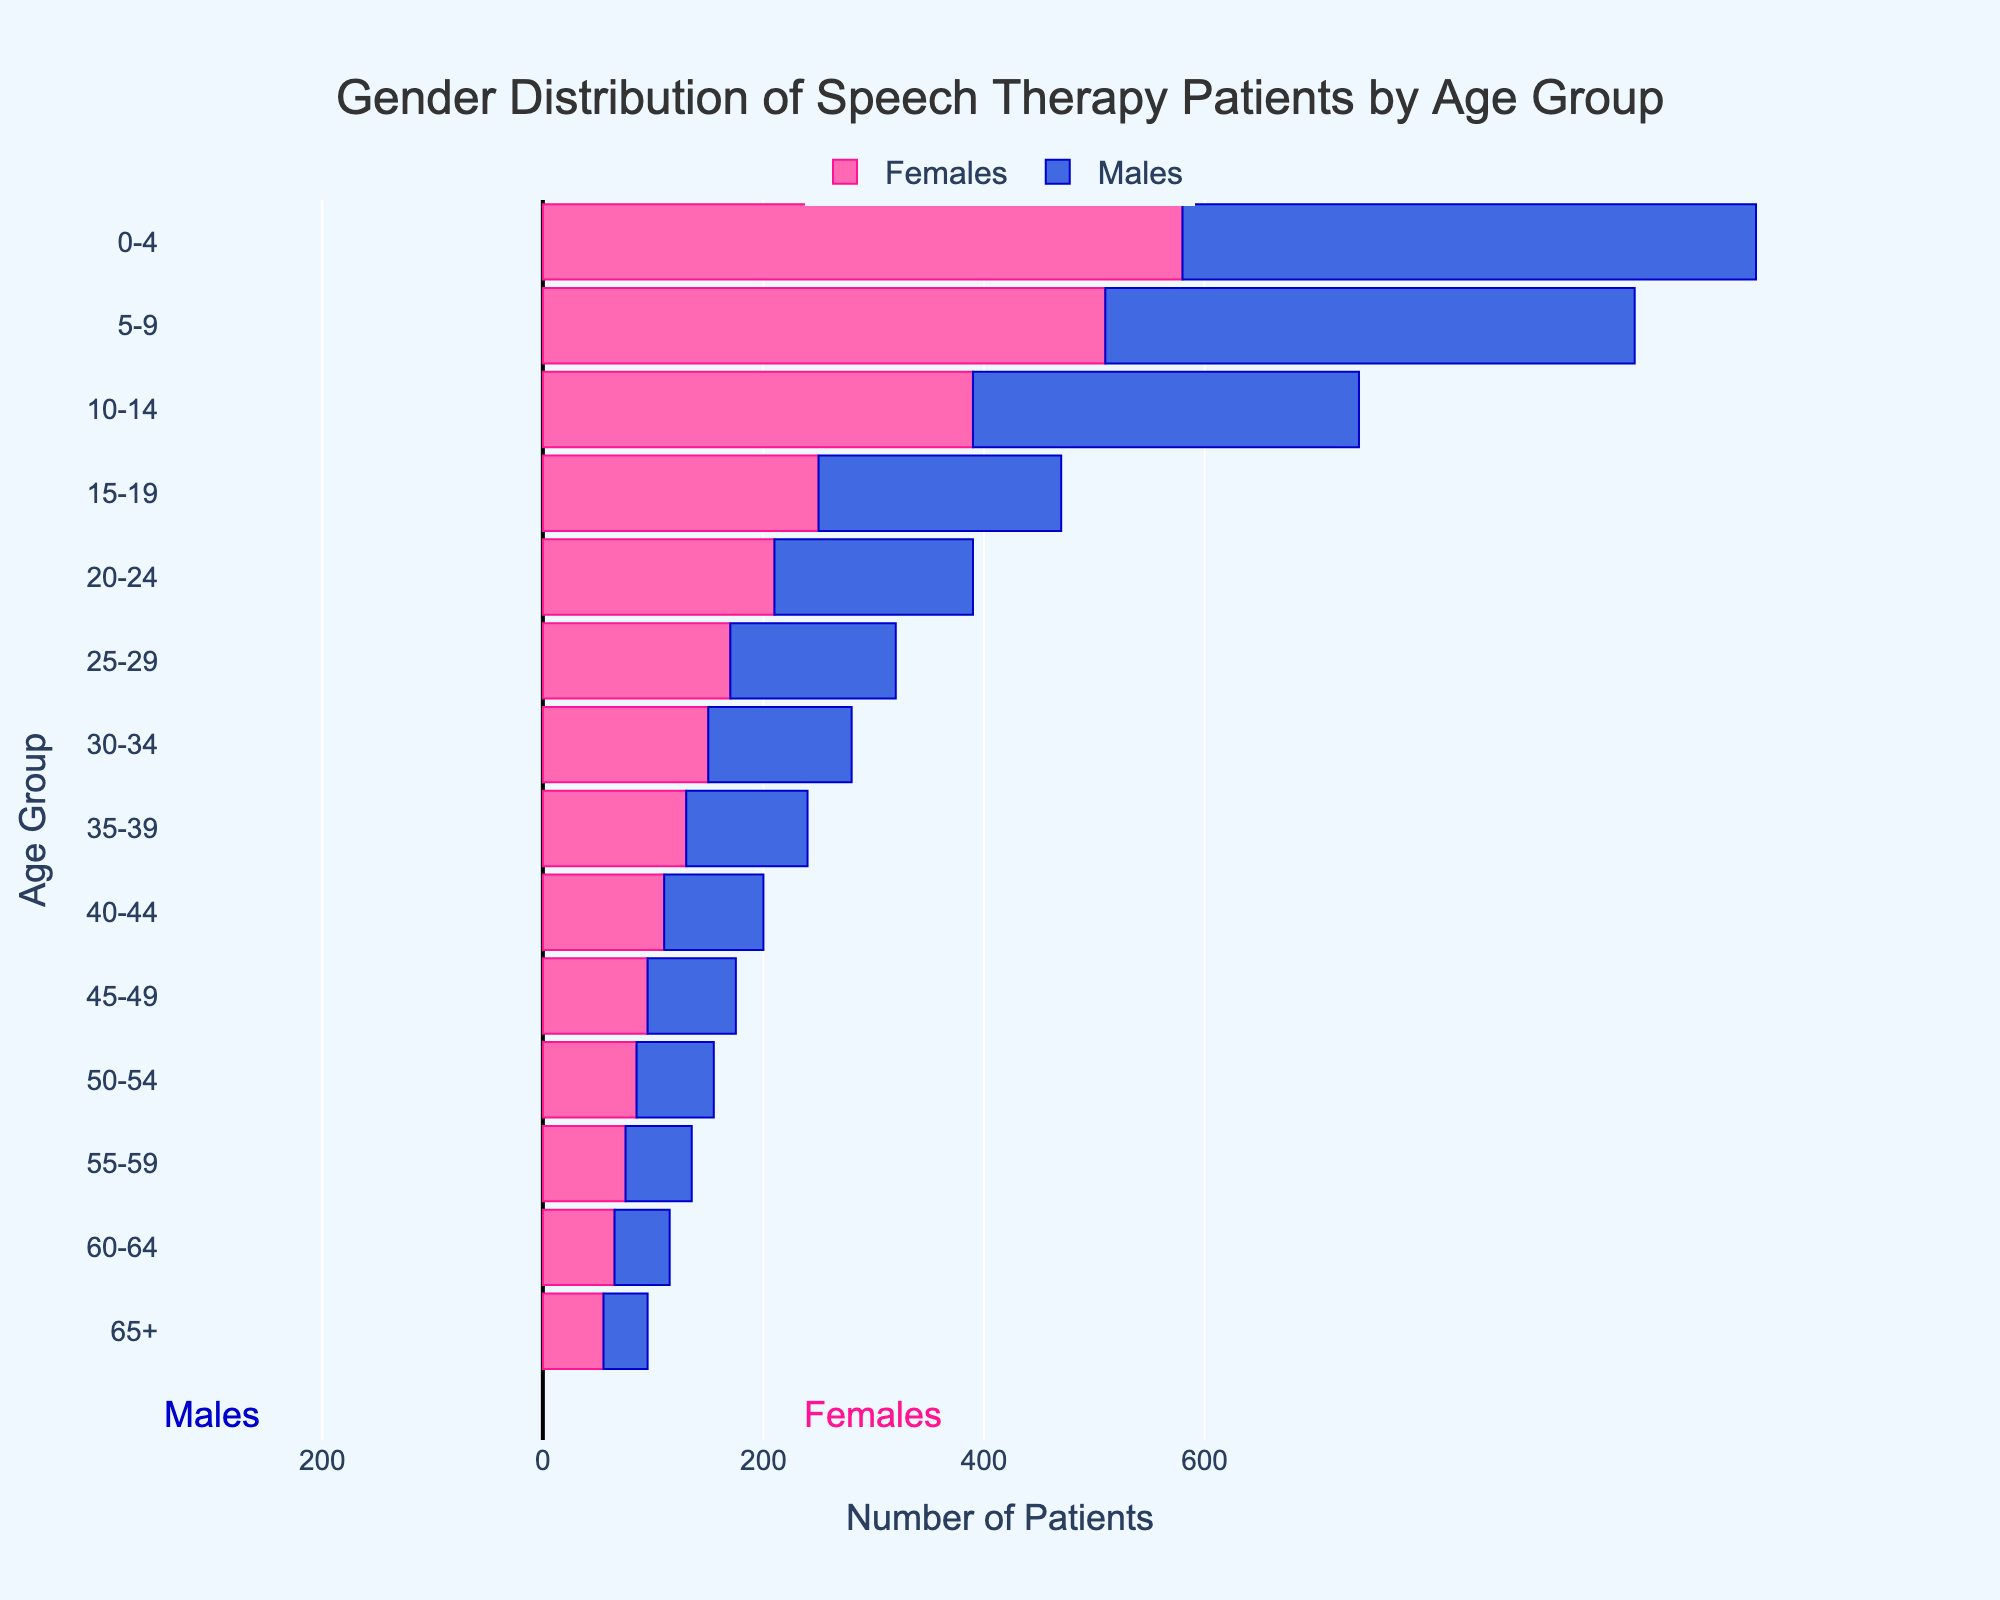What is the age group with the highest number of male patients seeking speech therapy? The age group with the highest number of male patients has the longest bar extending to the left. In this case, the age group 0-4 has the most male patients with a count of 520.
Answer: 0-4 Which age group has more female patients, 10-14 or 30-34? To answer this, compare the lengths of the bars extending to the right for the age groups 10-14 and 30-34. The age group 10-14 has 390 female patients while 30-34 has 150 female patients. 10-14 has more female patients.
Answer: 10-14 What is the total number of patients (males and females) in the 20-24 age group? Add the number of male and female patients in the 20-24 age group. Males: 180 + Females: 210 = 390.
Answer: 390 Are there more males or females in the 15-19 age group? Compare the lengths of the bars for males and females in the 15-19 age group. The bar for females (250) is longer than that for males (220).
Answer: Females What is the difference in the number of patients between the youngest age group (0-4) and the oldest age group (65+)? Calculate the total number of patients in each age group and find the difference. For 0-4: Males: 520 + Females: 580 = 1100. For 65+: Males: 40 + Females: 55 = 95. The difference is 1100 - 95 = 1005.
Answer: 1005 Which gender has a higher total number of patients across all age groups? Sum the total number of male and female patients across all age groups. Total males: 520 + 480 + 350 + 220 + 180 + 150 + 130 + 110 + 90 + 80 + 70 + 60 + 50 + 40 = 2530. Total females: 580 + 510 + 390 + 250 + 210 + 170 + 150 + 130 + 110 + 95 + 85 + 75 + 65 + 55 = 2875. Females have more total patients.
Answer: Females What is the smallest age group for each gender? Look for the shortest bar on each side of the pyramid. For males, the 65+ age group has the least (40). For females, the 65+ age group has the least (55).
Answer: 65+ for both How does the number of males in the 45-49 age group compare to that in the 50-54 age group? Compare the lengths of the bars extending to the left for the 45-49 (80) and 50-54 (70) age groups. The 45-49 age group has more males than the 50-54 group.
Answer: 45-49 has more Is there an age group where the number of male and female patients is exactly the same? By examining each age group, we see that for all age groups, the number of male and female patients differs. Hence, there is no age group where the numbers are exactly the same.
Answer: No What is the trend in the number of patients as age increases? Observe the lengths of the bars from bottom to top, noting whether the bars generally get shorter or remain consistent as age increases. The general trend shows a decrease in the number of patients as age increases.
Answer: Decreasing 